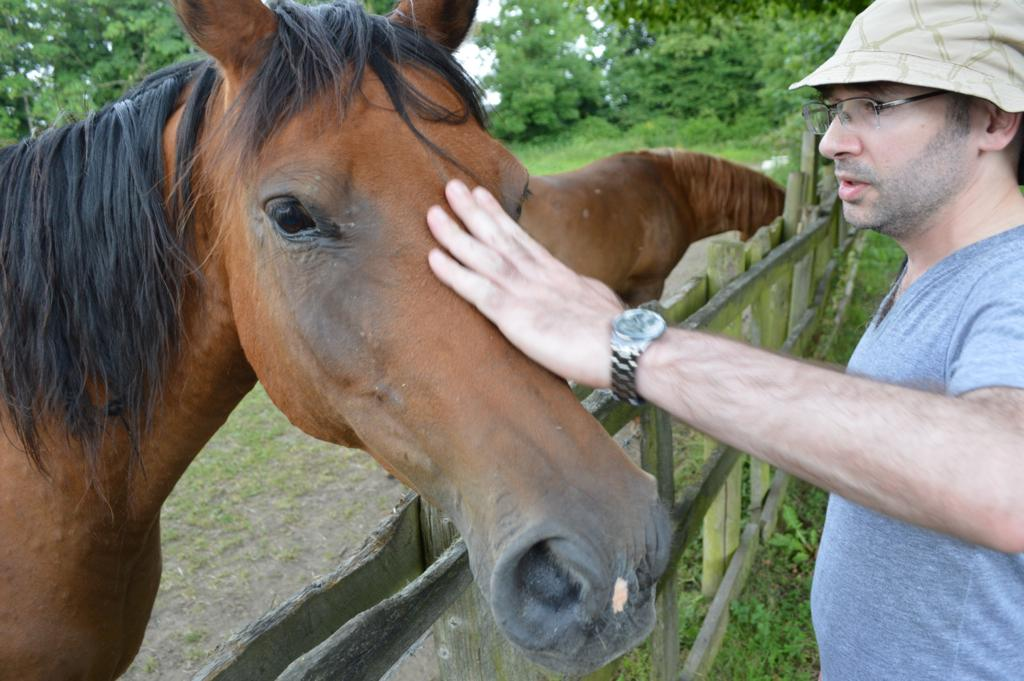How many horses are in the image? There are two horses in the image. What else can be seen in the image besides the horses? There is a man in the image. Can you describe the man's appearance? The man is wearing glasses, a watch, and a hat. What is visible in the background of the image? There are trees in the background of the image. What type of riddle is the man solving in the image? There is no indication in the image that the man is solving a riddle. What color is the butter on the man's sweater in the image? There is no butter or sweater present in the image. 